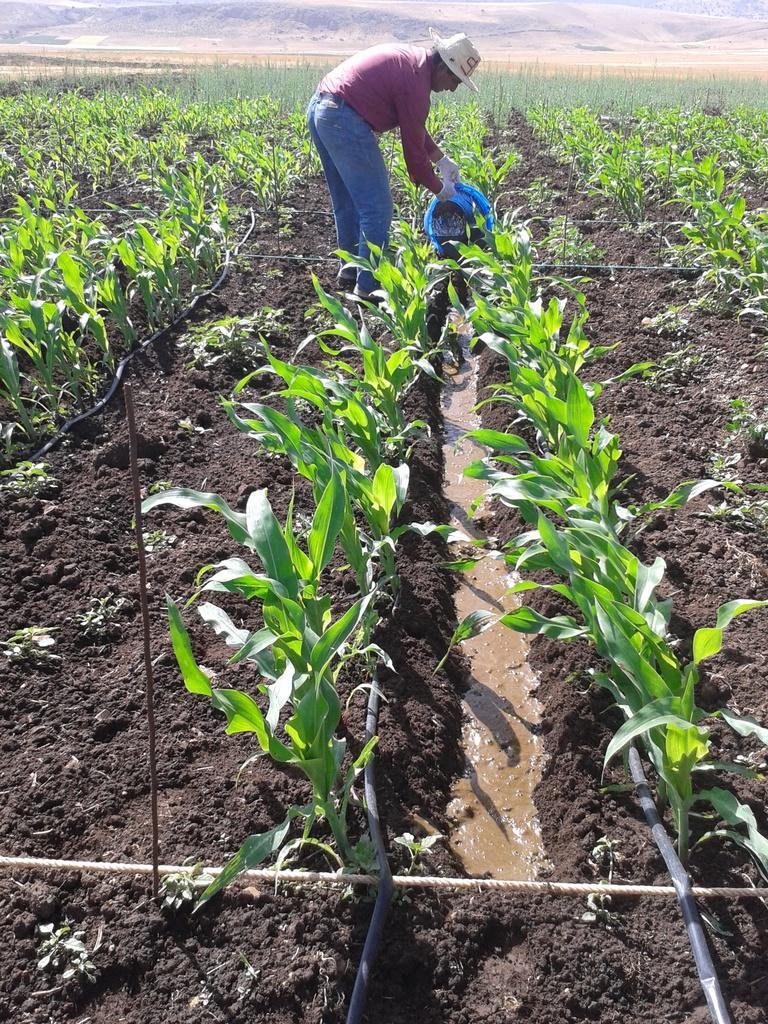Who is present in the image? There is a man in the image. What is the man doing in the image? The man is standing in the image. What is the man holding in the image? The man is holding an object in the image. What can be seen in the background of the image? There is water and plants visible in the image. What is the condition of the sky in the image? The sky is clear in the image. What type of baseball is the man playing in the image? There is no mention of baseball in the image. 